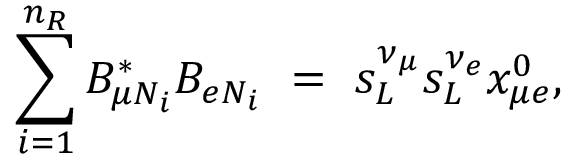Convert formula to latex. <formula><loc_0><loc_0><loc_500><loc_500>\sum _ { i = 1 } ^ { n _ { R } } B _ { \mu N _ { i } } ^ { * } B _ { e N _ { i } } \ = \ s _ { L } ^ { \nu _ { \mu } } s _ { L } ^ { \nu _ { e } } x _ { \mu e } ^ { 0 } ,</formula> 